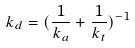<formula> <loc_0><loc_0><loc_500><loc_500>k _ { d } = ( \frac { 1 } { k _ { a } } + \frac { 1 } { k _ { t } } ) ^ { - 1 }</formula> 